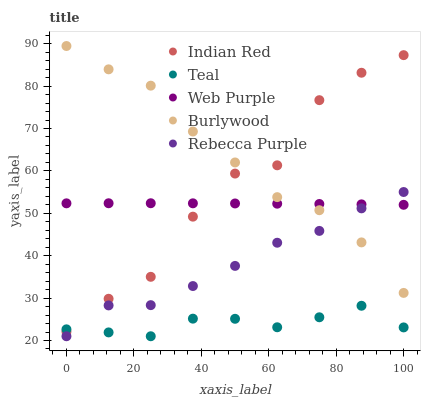Does Teal have the minimum area under the curve?
Answer yes or no. Yes. Does Burlywood have the maximum area under the curve?
Answer yes or no. Yes. Does Web Purple have the minimum area under the curve?
Answer yes or no. No. Does Web Purple have the maximum area under the curve?
Answer yes or no. No. Is Web Purple the smoothest?
Answer yes or no. Yes. Is Indian Red the roughest?
Answer yes or no. Yes. Is Teal the smoothest?
Answer yes or no. No. Is Teal the roughest?
Answer yes or no. No. Does Teal have the lowest value?
Answer yes or no. Yes. Does Web Purple have the lowest value?
Answer yes or no. No. Does Burlywood have the highest value?
Answer yes or no. Yes. Does Web Purple have the highest value?
Answer yes or no. No. Is Teal less than Web Purple?
Answer yes or no. Yes. Is Web Purple greater than Teal?
Answer yes or no. Yes. Does Indian Red intersect Burlywood?
Answer yes or no. Yes. Is Indian Red less than Burlywood?
Answer yes or no. No. Is Indian Red greater than Burlywood?
Answer yes or no. No. Does Teal intersect Web Purple?
Answer yes or no. No. 